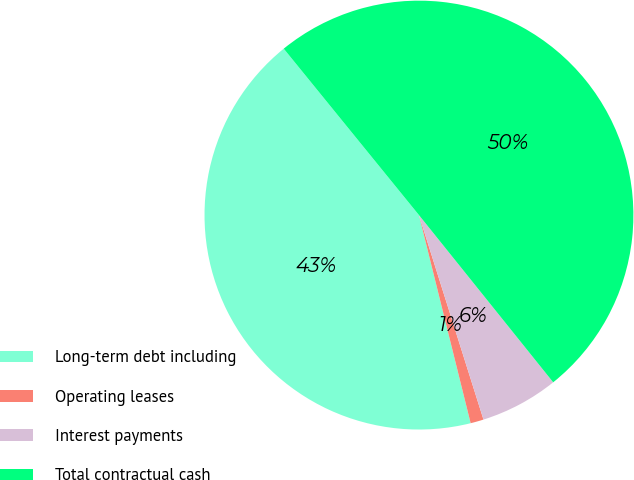<chart> <loc_0><loc_0><loc_500><loc_500><pie_chart><fcel>Long-term debt including<fcel>Operating leases<fcel>Interest payments<fcel>Total contractual cash<nl><fcel>43.01%<fcel>0.99%<fcel>5.9%<fcel>50.09%<nl></chart> 